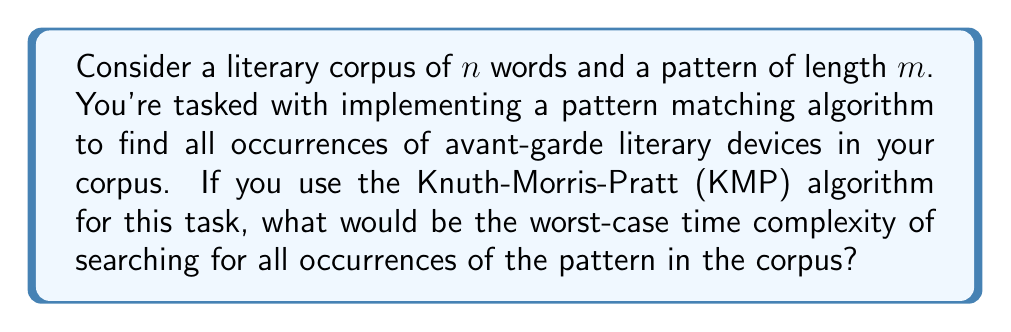Could you help me with this problem? To solve this problem, let's break it down step by step:

1) The Knuth-Morris-Pratt (KMP) algorithm is an efficient string matching algorithm that improves upon the naive approach of pattern matching.

2) The KMP algorithm consists of two main phases:
   a) Preprocessing phase: Building the failure function
   b) Searching phase: Matching the pattern against the text

3) Preprocessing phase:
   - This phase builds the failure function (also known as the prefix function) for the pattern.
   - The time complexity of this phase is $O(m)$, where $m$ is the length of the pattern.

4) Searching phase:
   - In this phase, the algorithm scans through the text, comparing it with the pattern.
   - The key feature of KMP is that it doesn't backtrack in the text; it uses the information from the failure function to skip unnecessary comparisons.
   - In the worst case, it makes $n$ comparisons, where $n$ is the length of the text (corpus in this case).

5) Total time complexity:
   - The total time complexity is the sum of the preprocessing and searching phases.
   - Therefore, the worst-case time complexity is $O(m) + O(n) = O(m + n)$.

6) In the context of literary corpus searches:
   - The corpus size $n$ is typically much larger than the pattern length $m$.
   - As $n$ grows large, the $O(m)$ term becomes insignificant compared to $O(n)$.

7) Therefore, for practical purposes in corpus linguistics, we often simplify this to $O(n)$.

This linear time complexity is a significant improvement over the naive approach, which has a worst-case time complexity of $O(mn)$. It allows for efficient searching of literary devices or patterns even in very large corpora, making it suitable for avant-garde literature analysis where complex and lengthy patterns might be common.
Answer: The worst-case time complexity of the Knuth-Morris-Pratt (KMP) algorithm for searching all occurrences of a pattern in a corpus is $O(n + m)$, where $n$ is the length of the corpus and $m$ is the length of the pattern. In practical corpus linguistics applications where $n \gg m$, this is often simplified to $O(n)$. 